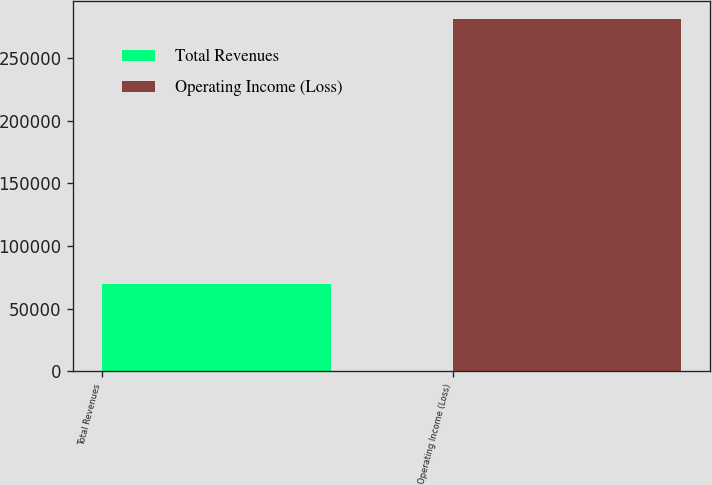<chart> <loc_0><loc_0><loc_500><loc_500><bar_chart><fcel>Total Revenues<fcel>Operating Income (Loss)<nl><fcel>70009<fcel>281593<nl></chart> 